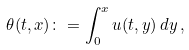Convert formula to latex. <formula><loc_0><loc_0><loc_500><loc_500>\theta ( t , x ) \colon = \int _ { 0 } ^ { x } u ( t , y ) \, d y \, ,</formula> 